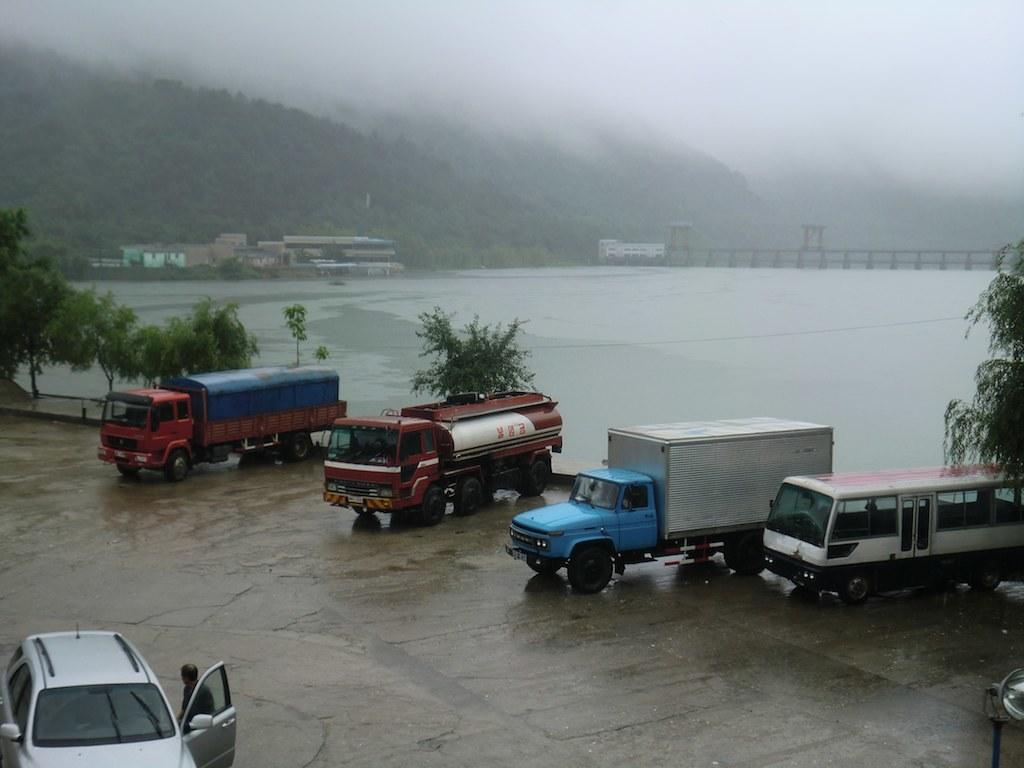What can be seen in the image besides the trees on the left side? There are vehicles in the image. What else is visible in the image? There is water visible in the image. What can be seen in the background of the image? There are trees and buildings in the background of the image. What type of teaching is happening in the image? There is no teaching or educational activity depicted in the image. How many babies are visible in the image? There are no babies present in the image. 